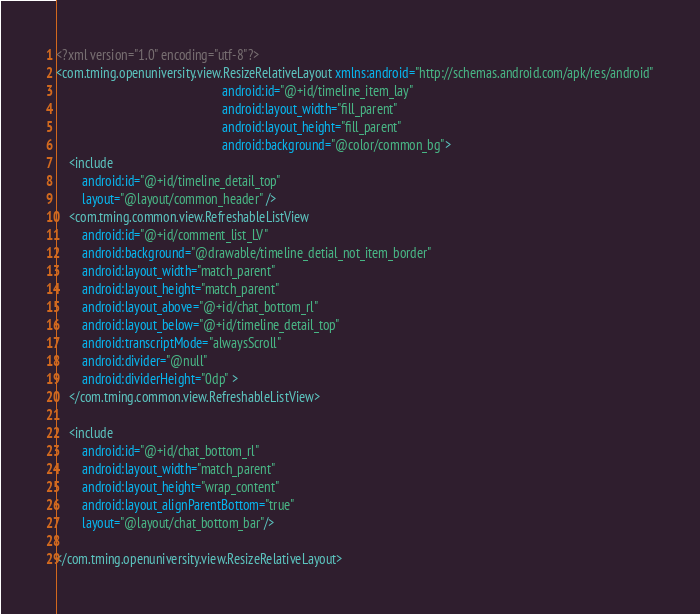Convert code to text. <code><loc_0><loc_0><loc_500><loc_500><_XML_><?xml version="1.0" encoding="utf-8"?>
<com.tming.openuniversity.view.ResizeRelativeLayout xmlns:android="http://schemas.android.com/apk/res/android"
                                                    android:id="@+id/timeline_item_lay"
                                                    android:layout_width="fill_parent"
                                                    android:layout_height="fill_parent"
                                                    android:background="@color/common_bg">
    <include
        android:id="@+id/timeline_detail_top"
        layout="@layout/common_header" />
    <com.tming.common.view.RefreshableListView 
        android:id="@+id/comment_list_LV"
        android:background="@drawable/timeline_detial_not_item_border"
        android:layout_width="match_parent"
        android:layout_height="match_parent"
        android:layout_above="@+id/chat_bottom_rl"
        android:layout_below="@+id/timeline_detail_top"
        android:transcriptMode="alwaysScroll"
        android:divider="@null"
        android:dividerHeight="0dp" >
    </com.tming.common.view.RefreshableListView>
    
    <include 
        android:id="@+id/chat_bottom_rl"
        android:layout_width="match_parent"
        android:layout_height="wrap_content"
        android:layout_alignParentBottom="true"
        layout="@layout/chat_bottom_bar"/>
    
</com.tming.openuniversity.view.ResizeRelativeLayout>
</code> 